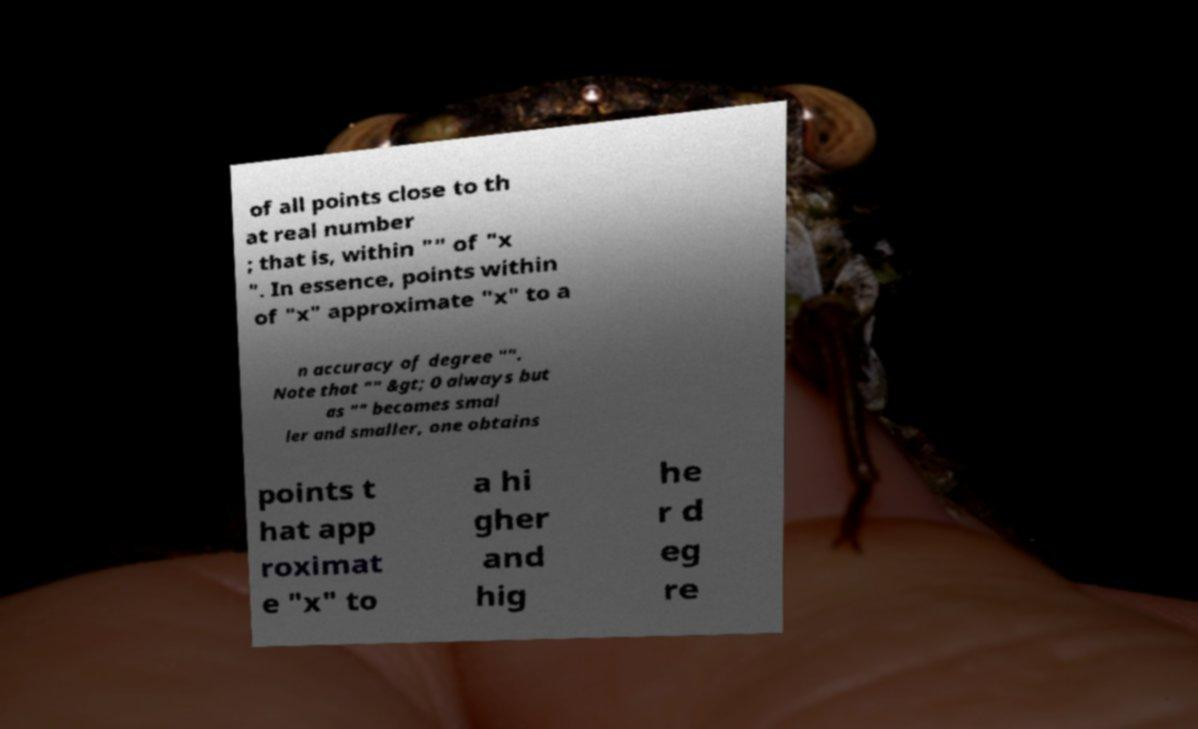What messages or text are displayed in this image? I need them in a readable, typed format. of all points close to th at real number ; that is, within "" of "x ". In essence, points within of "x" approximate "x" to a n accuracy of degree "". Note that "" &gt; 0 always but as "" becomes smal ler and smaller, one obtains points t hat app roximat e "x" to a hi gher and hig he r d eg re 